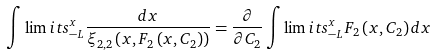Convert formula to latex. <formula><loc_0><loc_0><loc_500><loc_500>\int \lim i t s _ { - L } ^ { x } \frac { d x } { \xi _ { 2 , 2 } \left ( x , F _ { 2 } \left ( x , C _ { 2 } \right ) \right ) } = \frac { \partial } { \partial C _ { 2 } } \int \lim i t s _ { - L } ^ { x } F _ { 2 } \left ( x , C _ { 2 } \right ) d x</formula> 